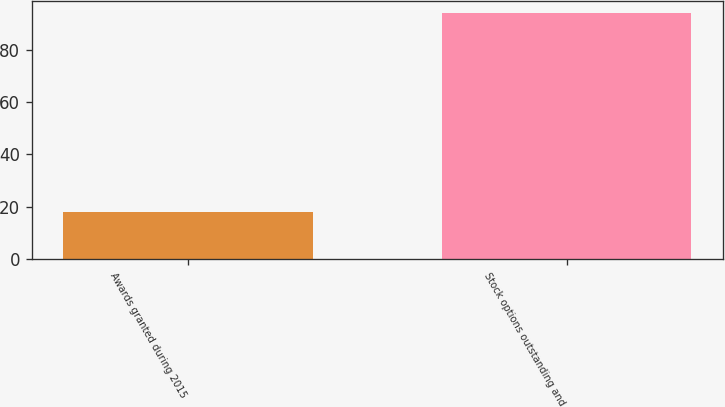<chart> <loc_0><loc_0><loc_500><loc_500><bar_chart><fcel>Awards granted during 2015<fcel>Stock options outstanding and<nl><fcel>18<fcel>94<nl></chart> 